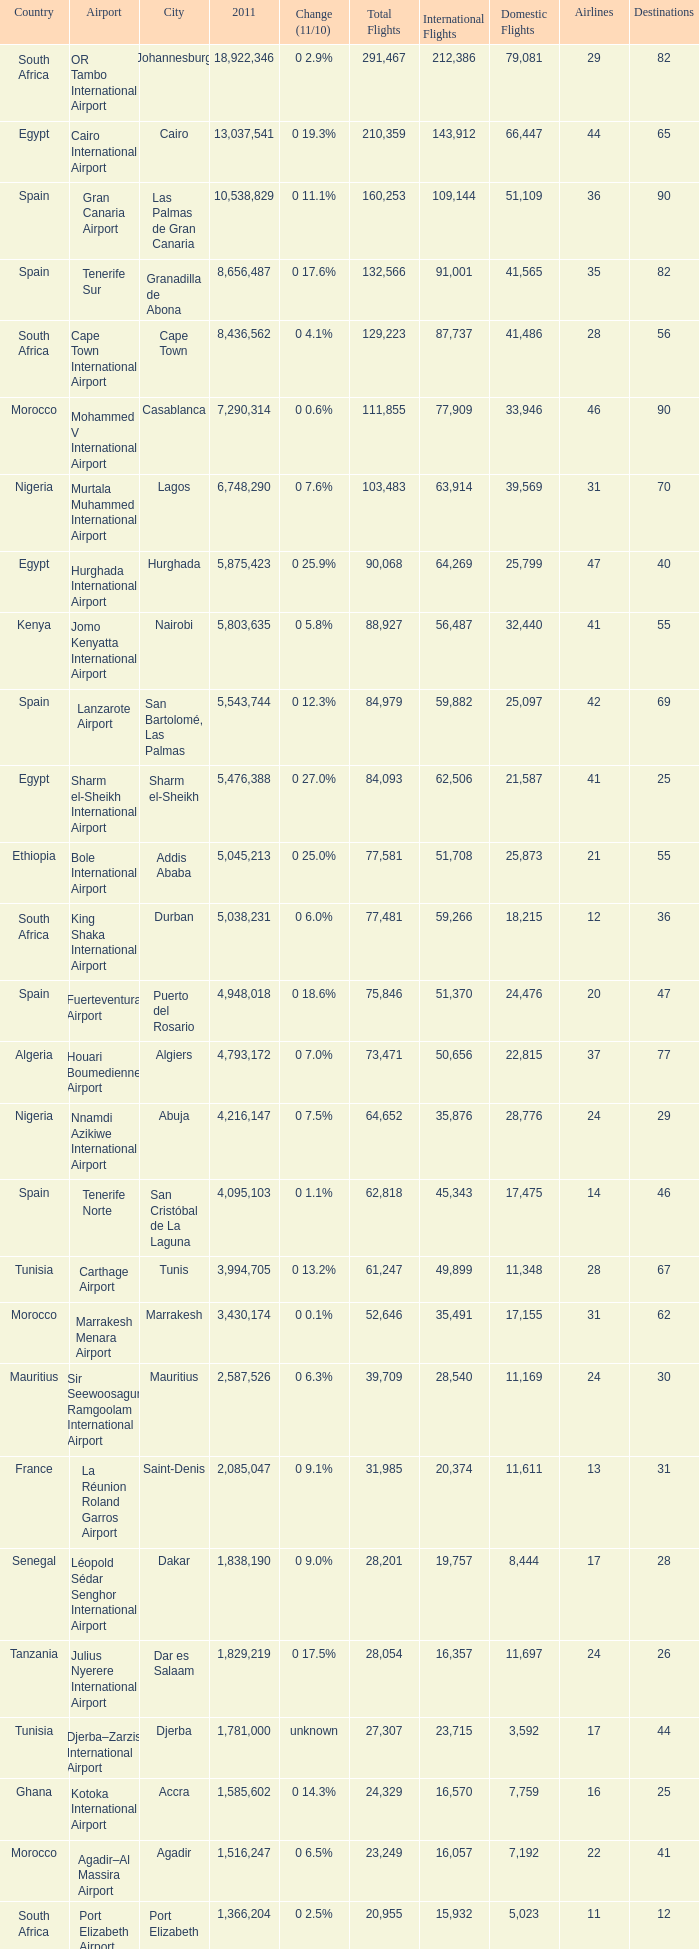Which 2011 has an Airport of bole international airport? 5045213.0. 